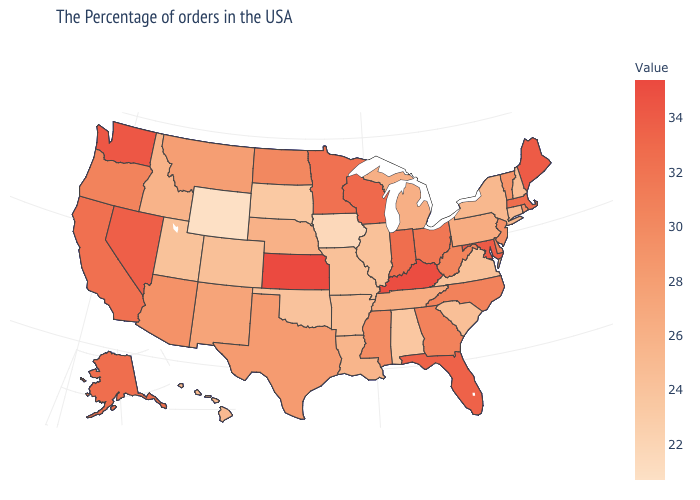Does the map have missing data?
Write a very short answer. No. Among the states that border North Carolina , which have the lowest value?
Be succinct. Virginia. Does Pennsylvania have the lowest value in the USA?
Give a very brief answer. No. Is the legend a continuous bar?
Be succinct. Yes. 